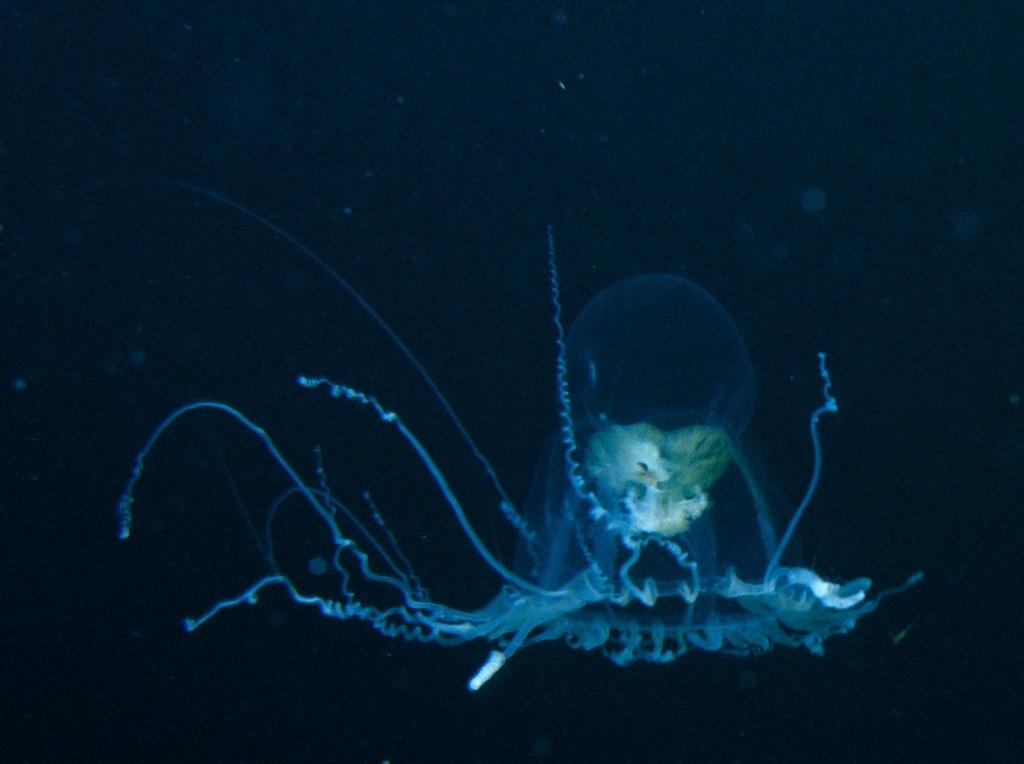What is the main subject of the image? There is a jellyfish in the center of the image. Can you describe the background of the image? The background of the image is dark. Where is the cushion located in the image? There is no cushion present in the image. What type of work is the farmer doing in the image? There is no farmer present in the image. 